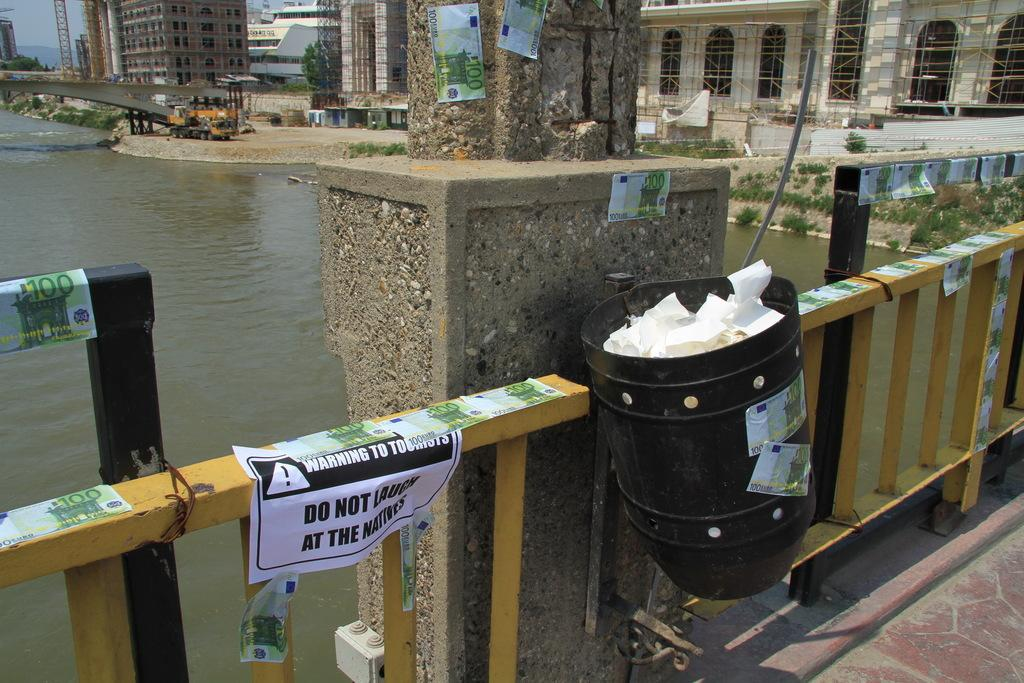<image>
Create a compact narrative representing the image presented. A bridge over a river with a paper sign that says Warning To Tourists. 